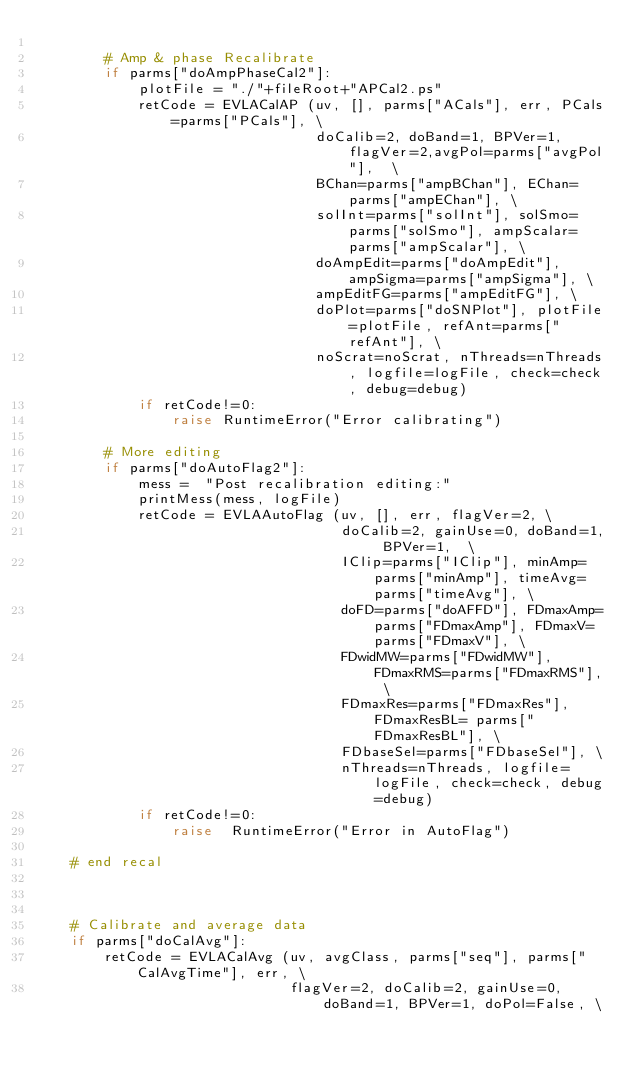Convert code to text. <code><loc_0><loc_0><loc_500><loc_500><_Python_>    
        # Amp & phase Recalibrate
        if parms["doAmpPhaseCal2"]:
            plotFile = "./"+fileRoot+"APCal2.ps"
            retCode = EVLACalAP (uv, [], parms["ACals"], err, PCals=parms["PCals"], \
                                 doCalib=2, doBand=1, BPVer=1, flagVer=2,avgPol=parms["avgPol"],  \
                                 BChan=parms["ampBChan"], EChan=parms["ampEChan"], \
                                 solInt=parms["solInt"], solSmo=parms["solSmo"], ampScalar=parms["ampScalar"], \
                                 doAmpEdit=parms["doAmpEdit"], ampSigma=parms["ampSigma"], \
                                 ampEditFG=parms["ampEditFG"], \
                                 doPlot=parms["doSNPlot"], plotFile=plotFile, refAnt=parms["refAnt"], \
                                 noScrat=noScrat, nThreads=nThreads, logfile=logFile, check=check, debug=debug)
            if retCode!=0:
                raise RuntimeError("Error calibrating")
    
        # More editing
        if parms["doAutoFlag2"]:
            mess =  "Post recalibration editing:"
            printMess(mess, logFile)
            retCode = EVLAAutoFlag (uv, [], err, flagVer=2, \
                                    doCalib=2, gainUse=0, doBand=1, BPVer=1,  \
                                    IClip=parms["IClip"], minAmp=parms["minAmp"], timeAvg=parms["timeAvg"], \
                                    doFD=parms["doAFFD"], FDmaxAmp=parms["FDmaxAmp"], FDmaxV=parms["FDmaxV"], \
                                    FDwidMW=parms["FDwidMW"], FDmaxRMS=parms["FDmaxRMS"], \
                                    FDmaxRes=parms["FDmaxRes"],  FDmaxResBL= parms["FDmaxResBL"], \
                                    FDbaseSel=parms["FDbaseSel"], \
                                    nThreads=nThreads, logfile=logFile, check=check, debug=debug)
            if retCode!=0:
                raise  RuntimeError("Error in AutoFlag")
            
    # end recal
    
    
    
    # Calibrate and average data
    if parms["doCalAvg"]:
        retCode = EVLACalAvg (uv, avgClass, parms["seq"], parms["CalAvgTime"], err, \
                              flagVer=2, doCalib=2, gainUse=0, doBand=1, BPVer=1, doPol=False, \</code> 